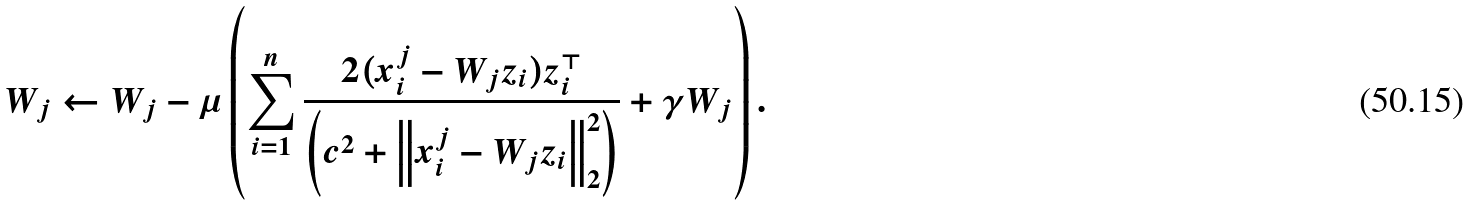Convert formula to latex. <formula><loc_0><loc_0><loc_500><loc_500>W _ { j } \leftarrow W _ { j } - \mu \left ( \sum _ { i = 1 } ^ { n } \frac { 2 ( x _ { i } ^ { j } - W _ { j } z _ { i } ) z _ { i } ^ { \top } } { \left ( c ^ { 2 } + \left \| x _ { i } ^ { j } - W _ { j } z _ { i } \right \| _ { 2 } ^ { 2 } \right ) } + \gamma W _ { j } \right ) .</formula> 